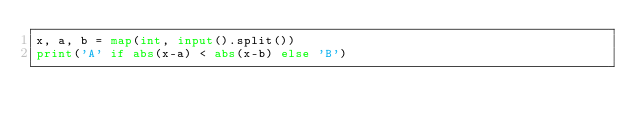Convert code to text. <code><loc_0><loc_0><loc_500><loc_500><_Python_>x, a, b = map(int, input().split())
print('A' if abs(x-a) < abs(x-b) else 'B')</code> 